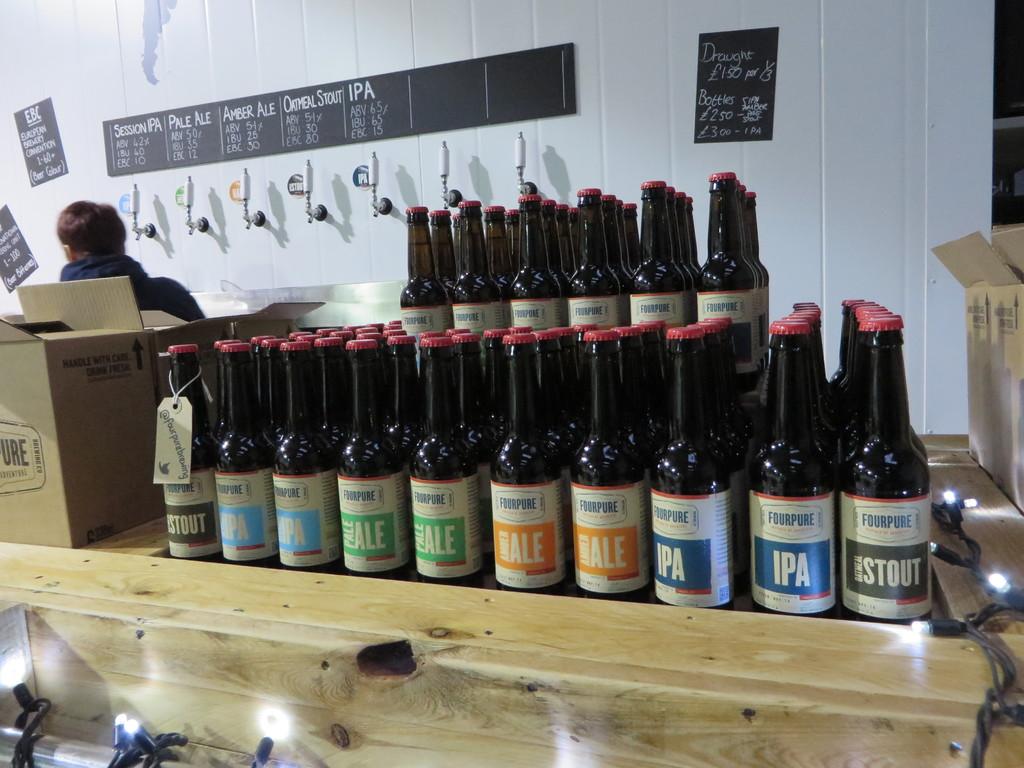What type of beer is packaged in the bottles on both ends?
Keep it short and to the point. Stout. What is the name of the beer that is 6th from the right?
Your answer should be compact. Pale ale. 